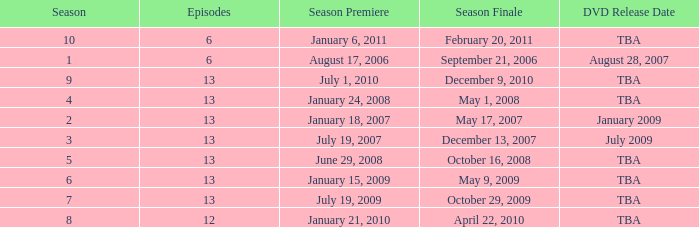On what date was the DVD released for the season with fewer than 13 episodes that aired before season 8? August 28, 2007. 